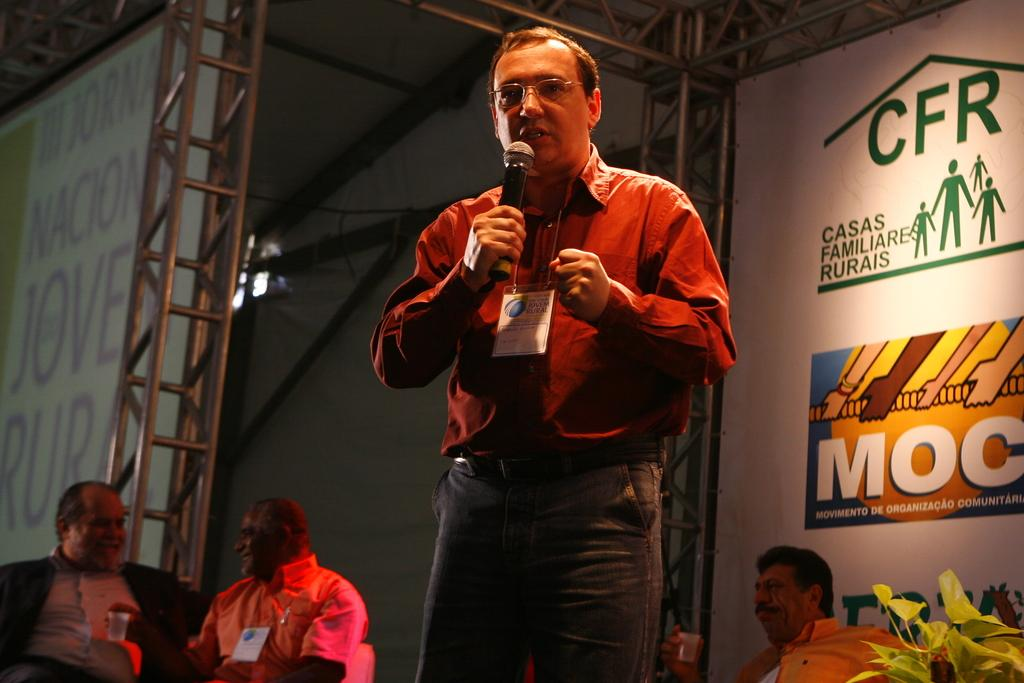What is the man in the image holding? The man is holding a microphone. How many other people are in the image besides the man with the microphone? There are three men sitting behind the man with the microphone. What might the man with the microphone be doing? The man with the microphone might be giving a speech or hosting an event. What type of popcorn is being served to the audience in the image? There is no popcorn present in the image. What tool is being used to turn the microphone on and off in the image? There is no tool or action of turning the microphone on or off depicted in the image. 